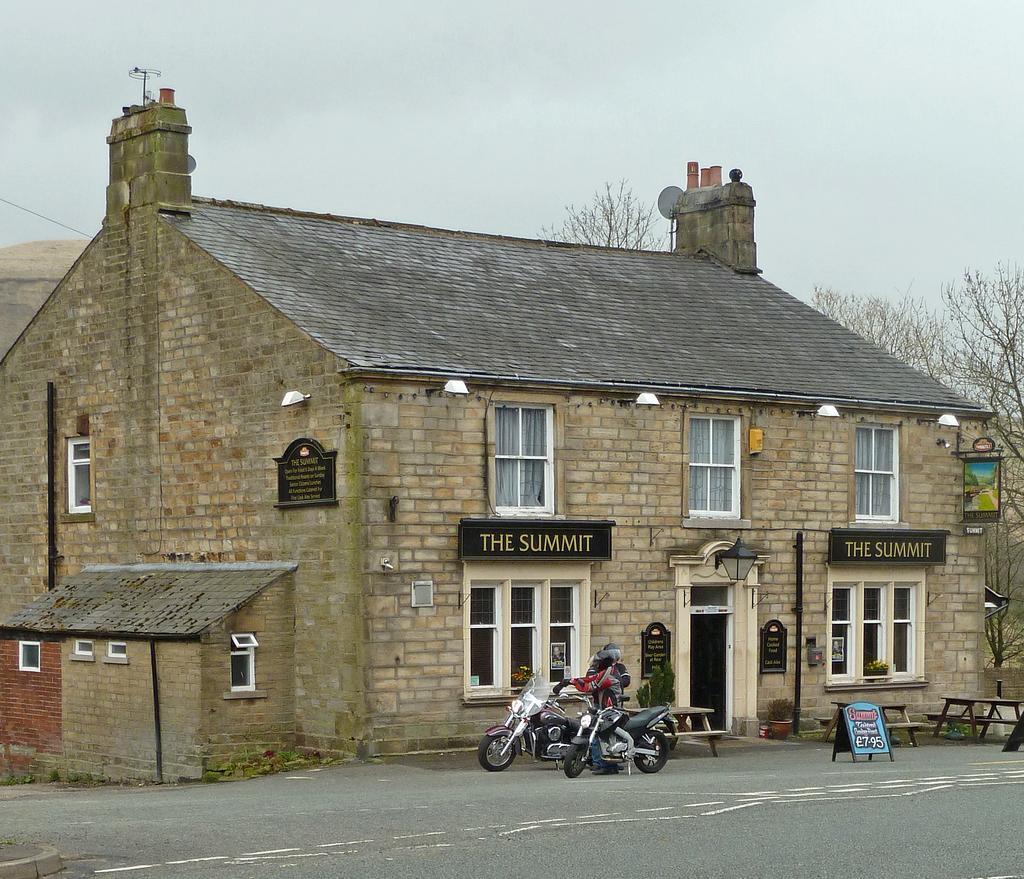Can you describe this image briefly? In this picture there is a person and we can see boards, benches and tables. We can see bikes on the road, plants and building. In the background of the image we can see trees and sky. 